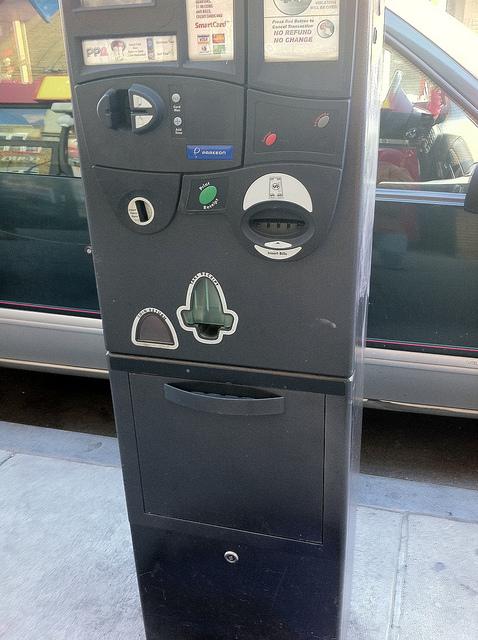Where is the car parked?
Write a very short answer. Street. What is this machine for?
Write a very short answer. Parking. Where is the machine located?
Answer briefly. On sidewalk. 